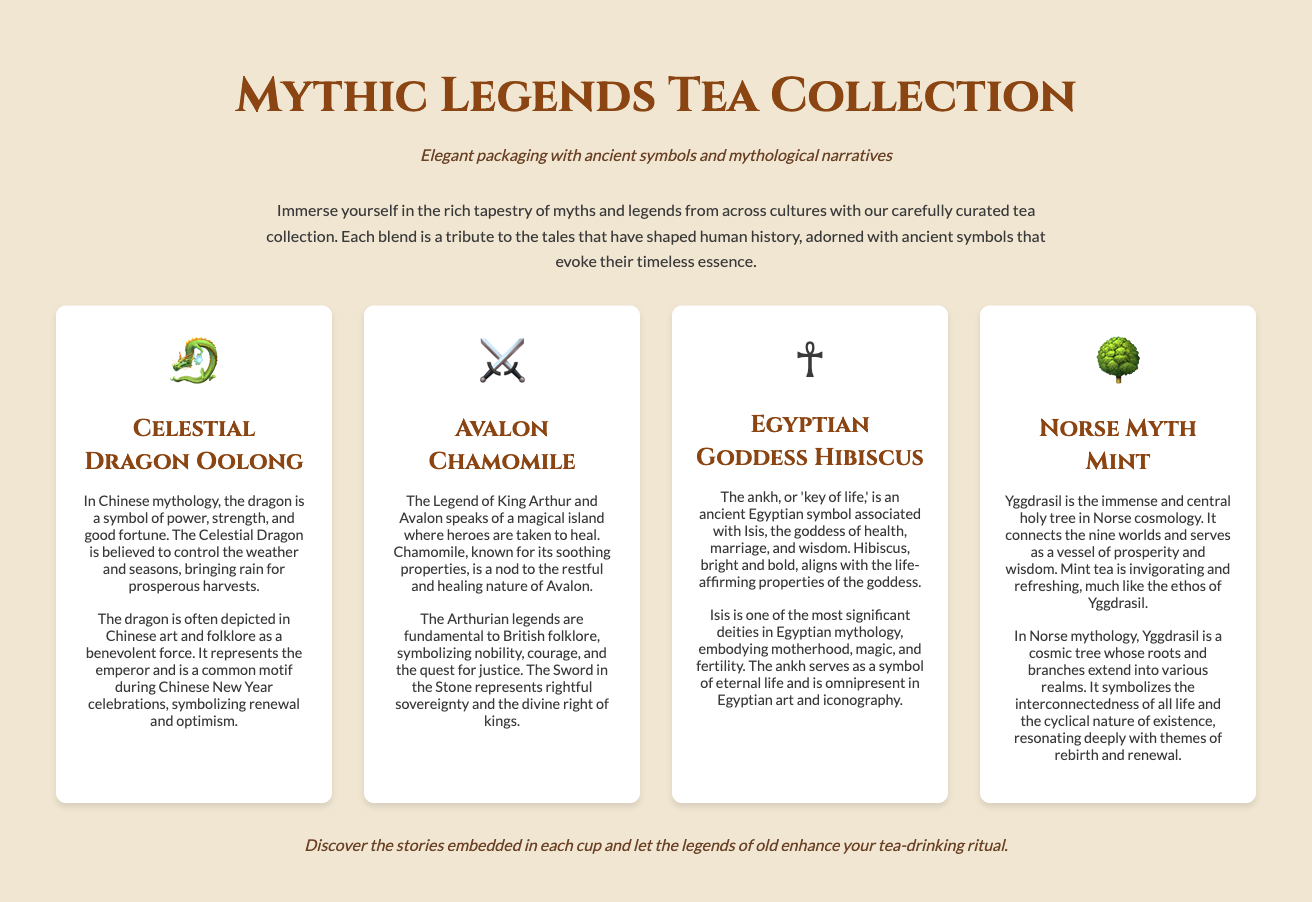What is the name of the first tea in the collection? The first tea listed in the collection is "Celestial Dragon Oolong."
Answer: Celestial Dragon Oolong What symbol represents the "Avalon Chamomile" tea? The symbol for "Avalon Chamomile" is a sword emoji (⚔️).
Answer: ⚔️ Which tea is associated with the goddess Isis? The tea associated with the goddess Isis is "Egyptian Goddess Hibiscus."
Answer: Egyptian Goddess Hibiscus What ancient symbol represents life in the Egyptian tea's narrative? The symbol that represents life is the ankh.
Answer: ankh Which tree is central in Norse mythology according to the document? The Yggdrasil tree is central in Norse mythology.
Answer: Yggdrasil What is the cultural significance of the dragon in the "Celestial Dragon Oolong"? The dragon represents power, strength, and good fortune in Chinese art and folklore.
Answer: power, strength, and good fortune How many types of tea are listed in the Mythic Legends Tea Collection? There are four types of tea listed in the collection.
Answer: four What is the tagline of the Mythic Legends Tea Collection? The tagline is "Elegant packaging with ancient symbols and mythological narratives."
Answer: Elegant packaging with ancient symbols and mythological narratives What does the mint tea's invigorating nature symbolize in Norse mythology? It symbolizes the ethos of Yggdrasil, which is prosperity and wisdom.
Answer: prosperity and wisdom 